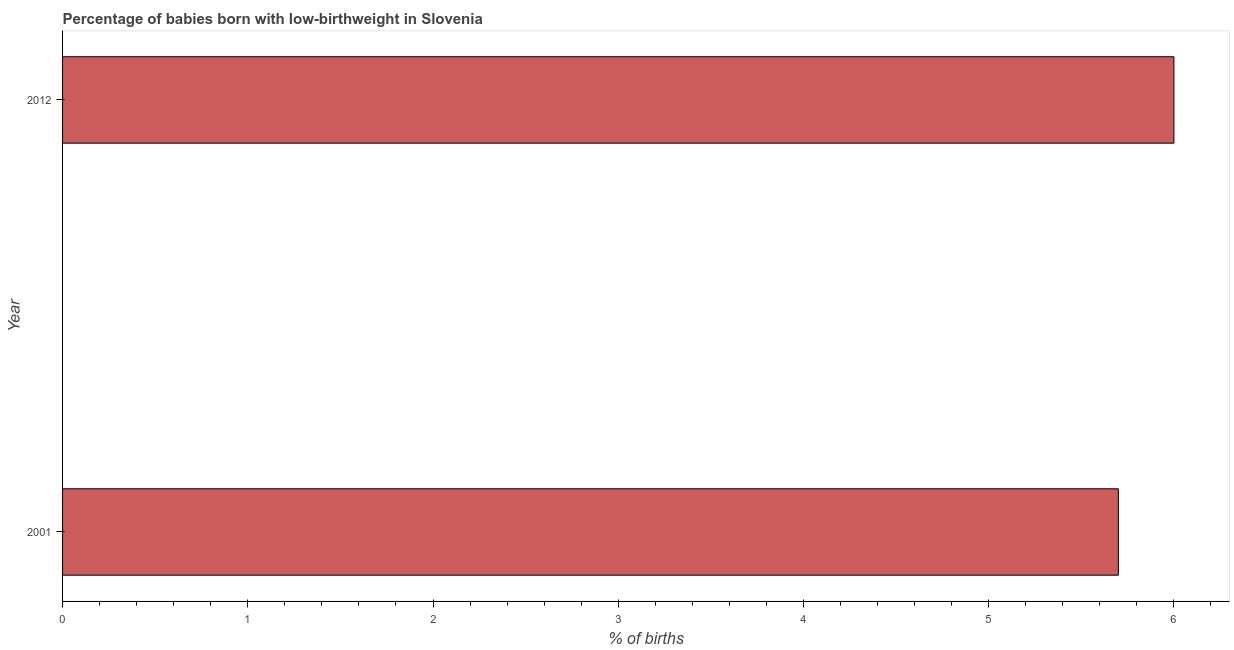Does the graph contain any zero values?
Your answer should be very brief. No. What is the title of the graph?
Keep it short and to the point. Percentage of babies born with low-birthweight in Slovenia. What is the label or title of the X-axis?
Offer a terse response. % of births. What is the label or title of the Y-axis?
Ensure brevity in your answer.  Year. In which year was the percentage of babies who were born with low-birthweight maximum?
Your answer should be very brief. 2012. In which year was the percentage of babies who were born with low-birthweight minimum?
Provide a short and direct response. 2001. What is the sum of the percentage of babies who were born with low-birthweight?
Your answer should be compact. 11.7. What is the difference between the percentage of babies who were born with low-birthweight in 2001 and 2012?
Provide a short and direct response. -0.3. What is the average percentage of babies who were born with low-birthweight per year?
Your response must be concise. 5.85. What is the median percentage of babies who were born with low-birthweight?
Ensure brevity in your answer.  5.85. Do a majority of the years between 2001 and 2012 (inclusive) have percentage of babies who were born with low-birthweight greater than 2 %?
Your answer should be very brief. Yes. What is the difference between two consecutive major ticks on the X-axis?
Make the answer very short. 1. What is the % of births in 2001?
Give a very brief answer. 5.7. What is the difference between the % of births in 2001 and 2012?
Offer a very short reply. -0.3. What is the ratio of the % of births in 2001 to that in 2012?
Your answer should be very brief. 0.95. 